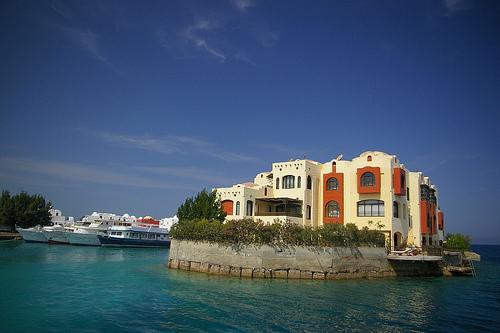What is over the water?
Short answer required. House. What is floating on the water?
Be succinct. Boat. How many boats are there?
Write a very short answer. 4. Is there a tower in this pic?
Answer briefly. No. Is this water crystal clear?
Answer briefly. Yes. What is the weather like?
Keep it brief. Sunny. Where was this picture taken?
Short answer required. Ocean. Could this be a marina?
Give a very brief answer. Yes. Is this picture from an old postcard?
Keep it brief. No. Is this a bright colored picture?
Short answer required. Yes. How many windows are visible on the enclosed porch of the building?
Answer briefly. 1. Is this a city?
Write a very short answer. No. Are there Gables?
Keep it brief. No. Are there mountains?
Answer briefly. No. Is this building on an island?
Quick response, please. Yes. What time of day is it?
Concise answer only. Daytime. Is this a private island?
Short answer required. Yes. Is the water clean?
Give a very brief answer. Yes. How is the weather in this beach scene?
Concise answer only. Sunny. 